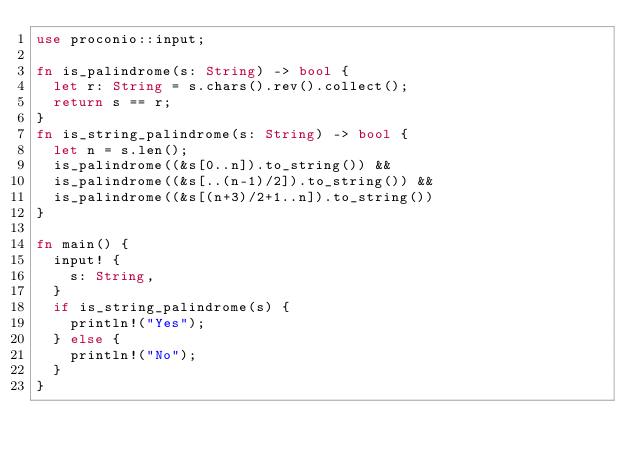Convert code to text. <code><loc_0><loc_0><loc_500><loc_500><_Rust_>use proconio::input;

fn is_palindrome(s: String) -> bool {
  let r: String = s.chars().rev().collect();
  return s == r;
}
fn is_string_palindrome(s: String) -> bool {
  let n = s.len();
  is_palindrome((&s[0..n]).to_string()) && 
  is_palindrome((&s[..(n-1)/2]).to_string()) &&
  is_palindrome((&s[(n+3)/2+1..n]).to_string())
}

fn main() {
  input! {
    s: String,
  }
  if is_string_palindrome(s) {
    println!("Yes");
  } else {
    println!("No");
  }
}
</code> 